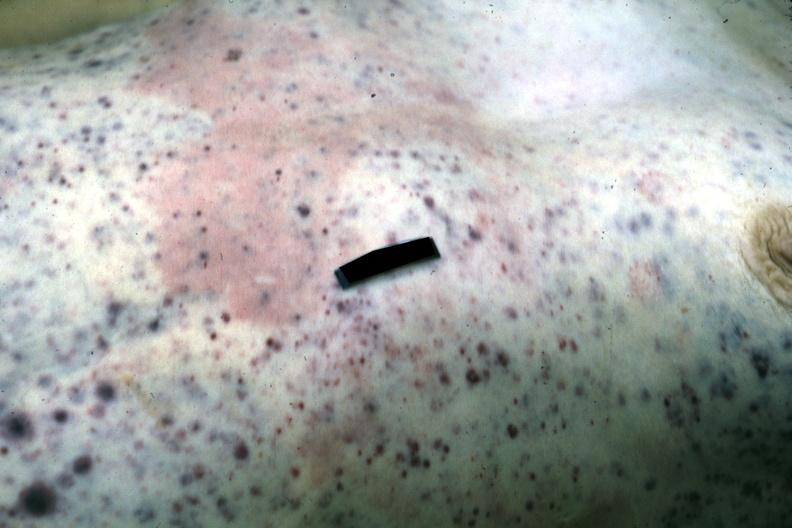where is this?
Answer the question using a single word or phrase. Skin 